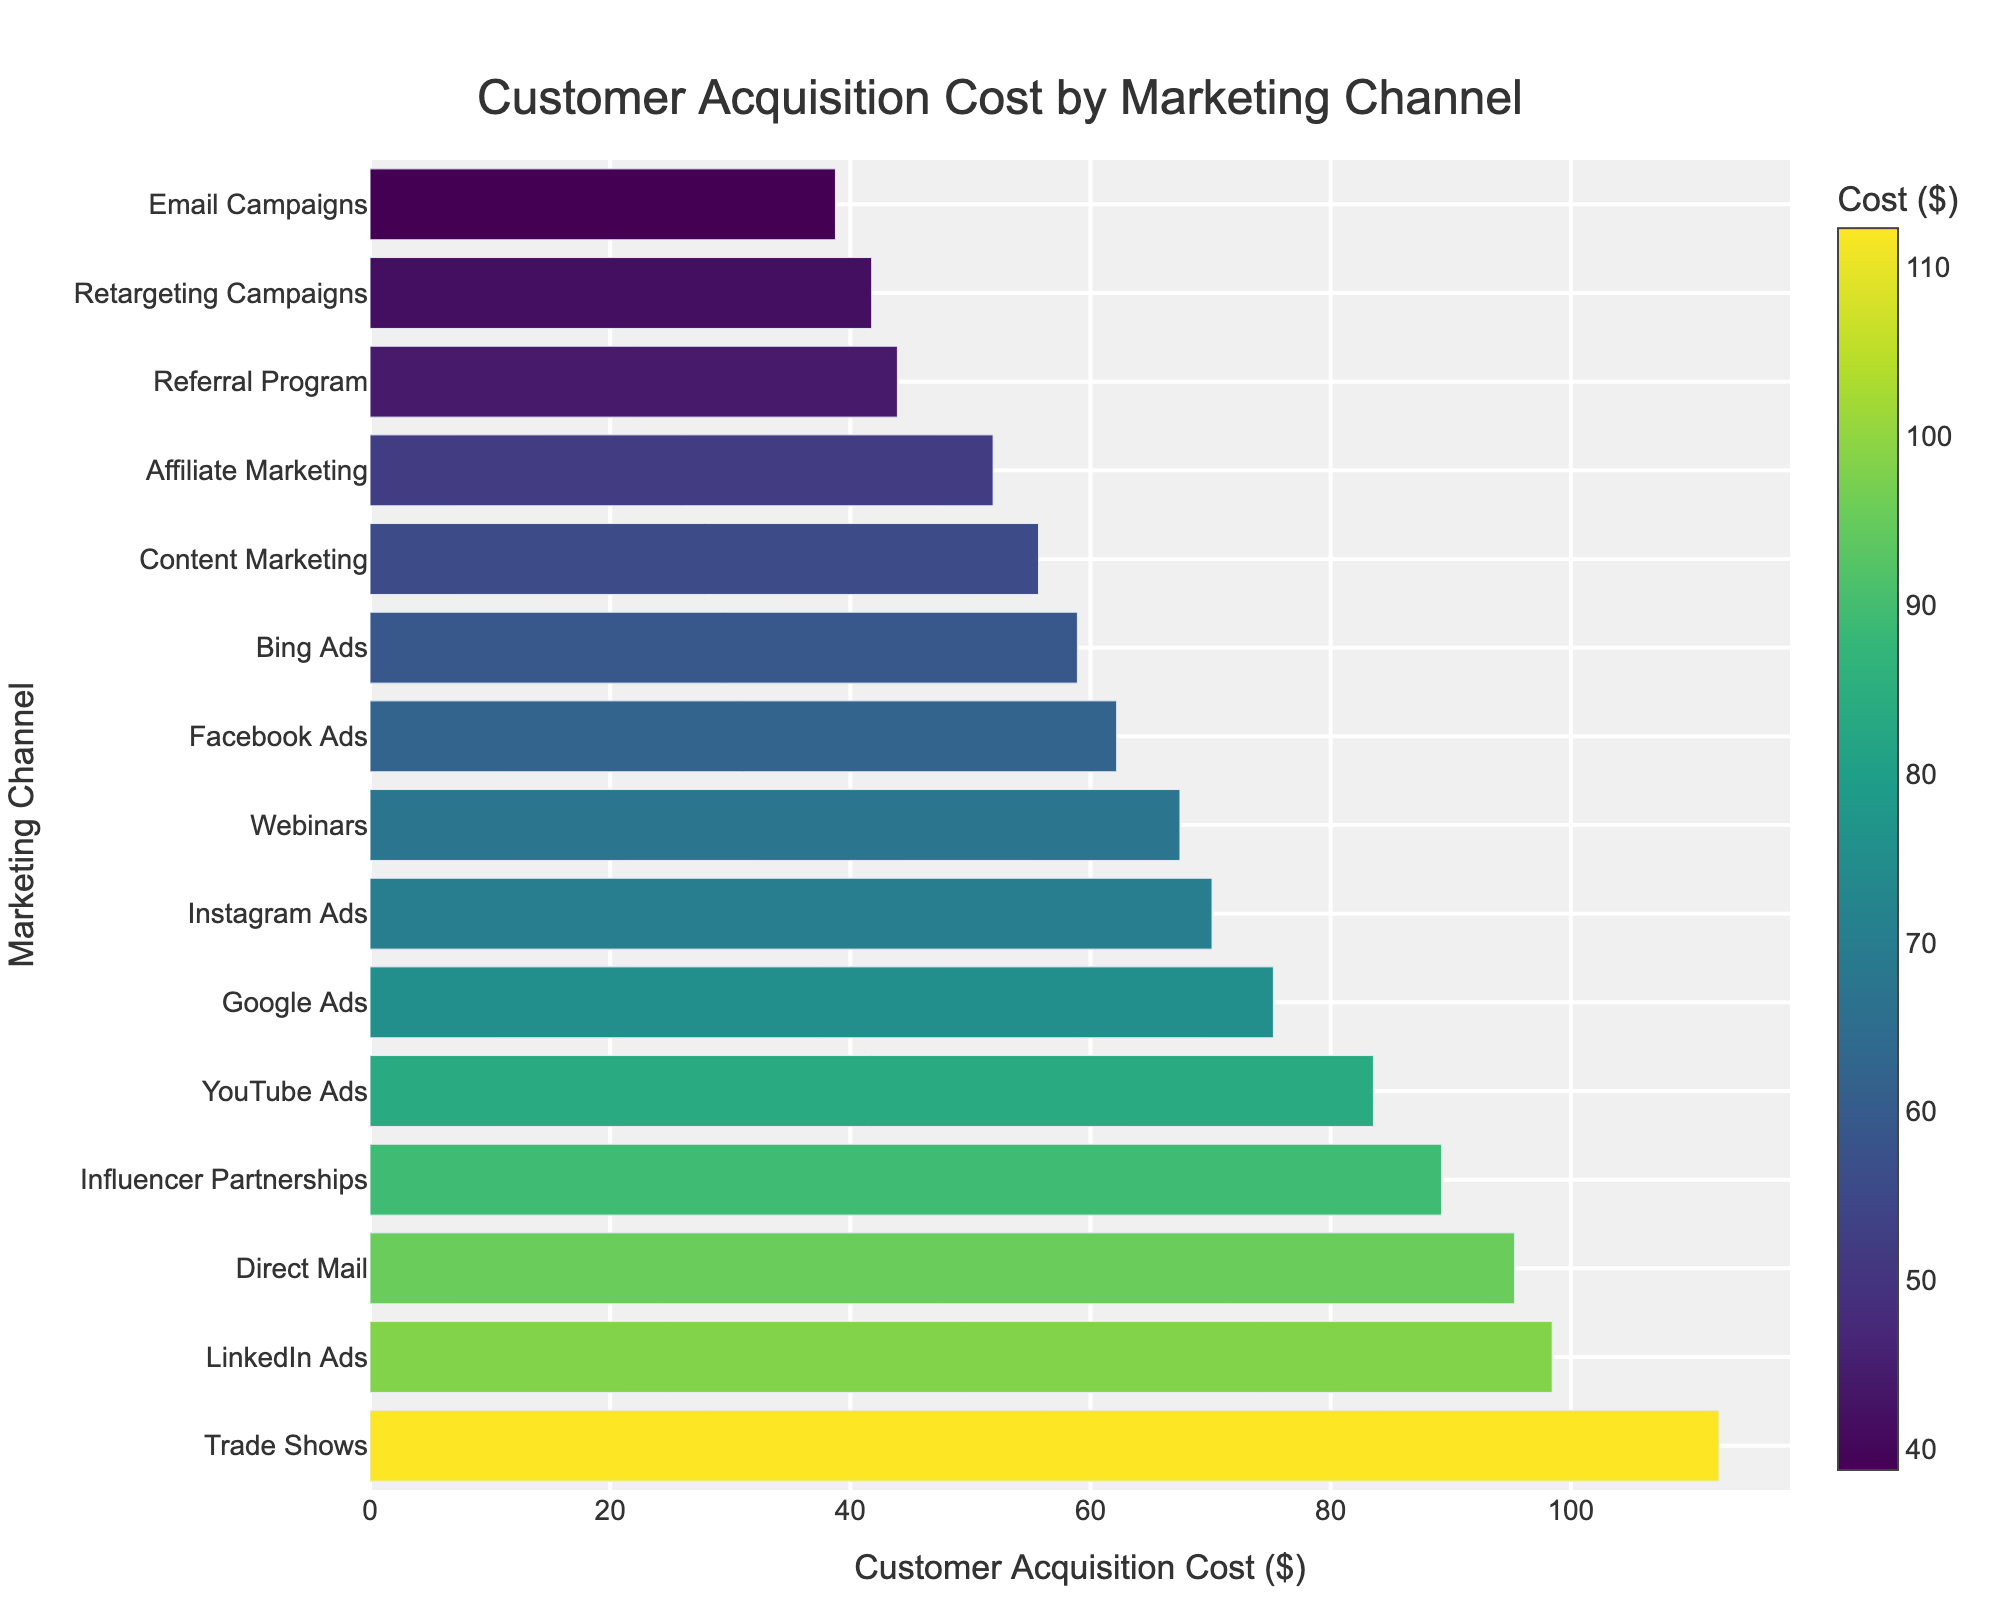Which marketing channel has the highest Customer Acquisition Cost? By looking at the bar chart, the longest bar corresponds to "Trade Shows", which indicates it has the highest Customer Acquisition Cost.
Answer: Trade Shows Which marketing channel has the lowest Customer Acquisition Cost? By observing the shortest bar in the bar chart, "Email Campaigns" is the channel with the lowest Customer Acquisition Cost.
Answer: Email Campaigns Compare the Customer Acquisition Costs of Google Ads and Facebook Ads. Which one is higher and by how much? Google Ads has a Customer Acquisition Cost of $75.23 while Facebook Ads has $62.18. The difference is $75.23 - $62.18.
Answer: Google Ads is higher by $13.05 What is the sum of Customer Acquisition Costs for LinkedIn Ads, Instagram Ads, and YouTube Ads? The costs for these channels are: LinkedIn Ads $98.45, Instagram Ads $70.12, and YouTube Ads $83.56. Summing them up: $98.45 + $70.12 + $83.56.
Answer: $252.13 Determine the average Customer Acquisition Cost for Trade Shows, Direct Mail, and Influencer Partnerships. The costs are: Trade Shows $112.34, Direct Mail $95.32, Influencer Partnerships $89.23. The average is ($112.34 + $95.32 + $89.23) / 3.
Answer: $99.63 By observing, which marketing channel falls around the median Customer Acquisition Cost? Ordering the costs, the median (8th value in sorted order) is "Instagram Ads" at $70.12.
Answer: Instagram Ads Is the Customer Acquisition Cost for Referrals less than that for Facebook Ads? The bar for the Referral Program ($43.92) is shorter than that for Facebook Ads ($62.18).
Answer: Yes Which marketing channels have Customer Acquisition Costs above $90? Channels with longer bars indicating costs above $90 are Trade Shows ($112.34), LinkedIn Ads ($98.45), Direct Mail ($95.32), and Influencer Partnerships ($89.23, though slightly below $90).
Answer: Trade Shows, LinkedIn Ads, Direct Mail 